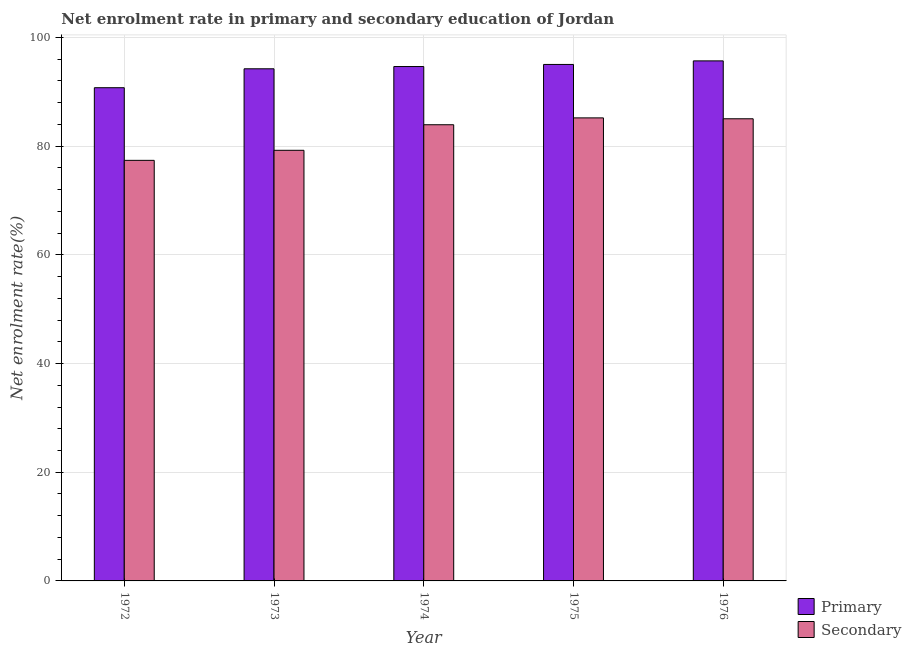How many different coloured bars are there?
Your response must be concise. 2. Are the number of bars per tick equal to the number of legend labels?
Make the answer very short. Yes. Are the number of bars on each tick of the X-axis equal?
Make the answer very short. Yes. How many bars are there on the 5th tick from the left?
Offer a terse response. 2. What is the label of the 2nd group of bars from the left?
Offer a very short reply. 1973. In how many cases, is the number of bars for a given year not equal to the number of legend labels?
Ensure brevity in your answer.  0. What is the enrollment rate in primary education in 1973?
Give a very brief answer. 94.23. Across all years, what is the maximum enrollment rate in primary education?
Your response must be concise. 95.69. Across all years, what is the minimum enrollment rate in primary education?
Keep it short and to the point. 90.75. In which year was the enrollment rate in secondary education maximum?
Provide a succinct answer. 1975. In which year was the enrollment rate in primary education minimum?
Provide a succinct answer. 1972. What is the total enrollment rate in primary education in the graph?
Make the answer very short. 470.35. What is the difference between the enrollment rate in primary education in 1974 and that in 1976?
Make the answer very short. -1.04. What is the difference between the enrollment rate in secondary education in 1972 and the enrollment rate in primary education in 1974?
Provide a short and direct response. -6.55. What is the average enrollment rate in secondary education per year?
Provide a short and direct response. 82.16. In the year 1975, what is the difference between the enrollment rate in secondary education and enrollment rate in primary education?
Keep it short and to the point. 0. What is the ratio of the enrollment rate in primary education in 1972 to that in 1976?
Offer a very short reply. 0.95. What is the difference between the highest and the second highest enrollment rate in primary education?
Your answer should be compact. 0.66. What is the difference between the highest and the lowest enrollment rate in primary education?
Make the answer very short. 4.94. In how many years, is the enrollment rate in secondary education greater than the average enrollment rate in secondary education taken over all years?
Offer a very short reply. 3. What does the 1st bar from the left in 1974 represents?
Your answer should be compact. Primary. What does the 2nd bar from the right in 1976 represents?
Offer a terse response. Primary. How many bars are there?
Give a very brief answer. 10. Are all the bars in the graph horizontal?
Your answer should be very brief. No. How many years are there in the graph?
Keep it short and to the point. 5. Are the values on the major ticks of Y-axis written in scientific E-notation?
Your answer should be very brief. No. How many legend labels are there?
Your answer should be compact. 2. What is the title of the graph?
Provide a short and direct response. Net enrolment rate in primary and secondary education of Jordan. What is the label or title of the X-axis?
Give a very brief answer. Year. What is the label or title of the Y-axis?
Your response must be concise. Net enrolment rate(%). What is the Net enrolment rate(%) of Primary in 1972?
Your response must be concise. 90.75. What is the Net enrolment rate(%) in Secondary in 1972?
Ensure brevity in your answer.  77.39. What is the Net enrolment rate(%) in Primary in 1973?
Your answer should be very brief. 94.23. What is the Net enrolment rate(%) in Secondary in 1973?
Make the answer very short. 79.23. What is the Net enrolment rate(%) of Primary in 1974?
Give a very brief answer. 94.65. What is the Net enrolment rate(%) in Secondary in 1974?
Offer a terse response. 83.94. What is the Net enrolment rate(%) of Primary in 1975?
Offer a very short reply. 95.03. What is the Net enrolment rate(%) in Secondary in 1975?
Provide a short and direct response. 85.2. What is the Net enrolment rate(%) in Primary in 1976?
Your response must be concise. 95.69. What is the Net enrolment rate(%) in Secondary in 1976?
Provide a succinct answer. 85.04. Across all years, what is the maximum Net enrolment rate(%) in Primary?
Make the answer very short. 95.69. Across all years, what is the maximum Net enrolment rate(%) of Secondary?
Your answer should be very brief. 85.2. Across all years, what is the minimum Net enrolment rate(%) in Primary?
Give a very brief answer. 90.75. Across all years, what is the minimum Net enrolment rate(%) in Secondary?
Your response must be concise. 77.39. What is the total Net enrolment rate(%) in Primary in the graph?
Make the answer very short. 470.35. What is the total Net enrolment rate(%) in Secondary in the graph?
Make the answer very short. 410.79. What is the difference between the Net enrolment rate(%) in Primary in 1972 and that in 1973?
Your answer should be compact. -3.48. What is the difference between the Net enrolment rate(%) in Secondary in 1972 and that in 1973?
Your answer should be very brief. -1.85. What is the difference between the Net enrolment rate(%) in Primary in 1972 and that in 1974?
Make the answer very short. -3.9. What is the difference between the Net enrolment rate(%) in Secondary in 1972 and that in 1974?
Your answer should be very brief. -6.55. What is the difference between the Net enrolment rate(%) in Primary in 1972 and that in 1975?
Provide a succinct answer. -4.28. What is the difference between the Net enrolment rate(%) of Secondary in 1972 and that in 1975?
Your response must be concise. -7.81. What is the difference between the Net enrolment rate(%) in Primary in 1972 and that in 1976?
Offer a terse response. -4.94. What is the difference between the Net enrolment rate(%) in Secondary in 1972 and that in 1976?
Offer a terse response. -7.65. What is the difference between the Net enrolment rate(%) in Primary in 1973 and that in 1974?
Your response must be concise. -0.41. What is the difference between the Net enrolment rate(%) of Secondary in 1973 and that in 1974?
Provide a succinct answer. -4.7. What is the difference between the Net enrolment rate(%) in Primary in 1973 and that in 1975?
Provide a short and direct response. -0.8. What is the difference between the Net enrolment rate(%) of Secondary in 1973 and that in 1975?
Keep it short and to the point. -5.97. What is the difference between the Net enrolment rate(%) in Primary in 1973 and that in 1976?
Ensure brevity in your answer.  -1.46. What is the difference between the Net enrolment rate(%) of Secondary in 1973 and that in 1976?
Keep it short and to the point. -5.8. What is the difference between the Net enrolment rate(%) in Primary in 1974 and that in 1975?
Ensure brevity in your answer.  -0.39. What is the difference between the Net enrolment rate(%) in Secondary in 1974 and that in 1975?
Give a very brief answer. -1.26. What is the difference between the Net enrolment rate(%) of Primary in 1974 and that in 1976?
Offer a terse response. -1.04. What is the difference between the Net enrolment rate(%) in Secondary in 1974 and that in 1976?
Your response must be concise. -1.1. What is the difference between the Net enrolment rate(%) in Primary in 1975 and that in 1976?
Offer a terse response. -0.66. What is the difference between the Net enrolment rate(%) in Secondary in 1975 and that in 1976?
Offer a terse response. 0.16. What is the difference between the Net enrolment rate(%) of Primary in 1972 and the Net enrolment rate(%) of Secondary in 1973?
Ensure brevity in your answer.  11.52. What is the difference between the Net enrolment rate(%) of Primary in 1972 and the Net enrolment rate(%) of Secondary in 1974?
Provide a succinct answer. 6.81. What is the difference between the Net enrolment rate(%) in Primary in 1972 and the Net enrolment rate(%) in Secondary in 1975?
Offer a terse response. 5.55. What is the difference between the Net enrolment rate(%) of Primary in 1972 and the Net enrolment rate(%) of Secondary in 1976?
Offer a very short reply. 5.71. What is the difference between the Net enrolment rate(%) in Primary in 1973 and the Net enrolment rate(%) in Secondary in 1974?
Your answer should be compact. 10.3. What is the difference between the Net enrolment rate(%) in Primary in 1973 and the Net enrolment rate(%) in Secondary in 1975?
Make the answer very short. 9.03. What is the difference between the Net enrolment rate(%) in Primary in 1973 and the Net enrolment rate(%) in Secondary in 1976?
Keep it short and to the point. 9.2. What is the difference between the Net enrolment rate(%) of Primary in 1974 and the Net enrolment rate(%) of Secondary in 1975?
Your response must be concise. 9.45. What is the difference between the Net enrolment rate(%) of Primary in 1974 and the Net enrolment rate(%) of Secondary in 1976?
Make the answer very short. 9.61. What is the difference between the Net enrolment rate(%) of Primary in 1975 and the Net enrolment rate(%) of Secondary in 1976?
Make the answer very short. 9.99. What is the average Net enrolment rate(%) in Primary per year?
Provide a succinct answer. 94.07. What is the average Net enrolment rate(%) of Secondary per year?
Your response must be concise. 82.16. In the year 1972, what is the difference between the Net enrolment rate(%) in Primary and Net enrolment rate(%) in Secondary?
Keep it short and to the point. 13.36. In the year 1974, what is the difference between the Net enrolment rate(%) in Primary and Net enrolment rate(%) in Secondary?
Provide a short and direct response. 10.71. In the year 1975, what is the difference between the Net enrolment rate(%) of Primary and Net enrolment rate(%) of Secondary?
Your answer should be very brief. 9.83. In the year 1976, what is the difference between the Net enrolment rate(%) of Primary and Net enrolment rate(%) of Secondary?
Provide a succinct answer. 10.65. What is the ratio of the Net enrolment rate(%) in Primary in 1972 to that in 1973?
Provide a succinct answer. 0.96. What is the ratio of the Net enrolment rate(%) of Secondary in 1972 to that in 1973?
Make the answer very short. 0.98. What is the ratio of the Net enrolment rate(%) of Primary in 1972 to that in 1974?
Make the answer very short. 0.96. What is the ratio of the Net enrolment rate(%) in Secondary in 1972 to that in 1974?
Make the answer very short. 0.92. What is the ratio of the Net enrolment rate(%) in Primary in 1972 to that in 1975?
Your response must be concise. 0.95. What is the ratio of the Net enrolment rate(%) in Secondary in 1972 to that in 1975?
Give a very brief answer. 0.91. What is the ratio of the Net enrolment rate(%) in Primary in 1972 to that in 1976?
Offer a very short reply. 0.95. What is the ratio of the Net enrolment rate(%) of Secondary in 1972 to that in 1976?
Offer a terse response. 0.91. What is the ratio of the Net enrolment rate(%) in Secondary in 1973 to that in 1974?
Your answer should be compact. 0.94. What is the ratio of the Net enrolment rate(%) in Secondary in 1973 to that in 1975?
Provide a short and direct response. 0.93. What is the ratio of the Net enrolment rate(%) in Primary in 1973 to that in 1976?
Provide a succinct answer. 0.98. What is the ratio of the Net enrolment rate(%) in Secondary in 1973 to that in 1976?
Ensure brevity in your answer.  0.93. What is the ratio of the Net enrolment rate(%) of Primary in 1974 to that in 1975?
Your response must be concise. 1. What is the ratio of the Net enrolment rate(%) of Secondary in 1974 to that in 1975?
Your response must be concise. 0.99. What is the ratio of the Net enrolment rate(%) of Primary in 1974 to that in 1976?
Your response must be concise. 0.99. What is the ratio of the Net enrolment rate(%) in Secondary in 1974 to that in 1976?
Keep it short and to the point. 0.99. What is the ratio of the Net enrolment rate(%) in Secondary in 1975 to that in 1976?
Give a very brief answer. 1. What is the difference between the highest and the second highest Net enrolment rate(%) in Primary?
Offer a very short reply. 0.66. What is the difference between the highest and the second highest Net enrolment rate(%) in Secondary?
Keep it short and to the point. 0.16. What is the difference between the highest and the lowest Net enrolment rate(%) of Primary?
Ensure brevity in your answer.  4.94. What is the difference between the highest and the lowest Net enrolment rate(%) in Secondary?
Offer a very short reply. 7.81. 